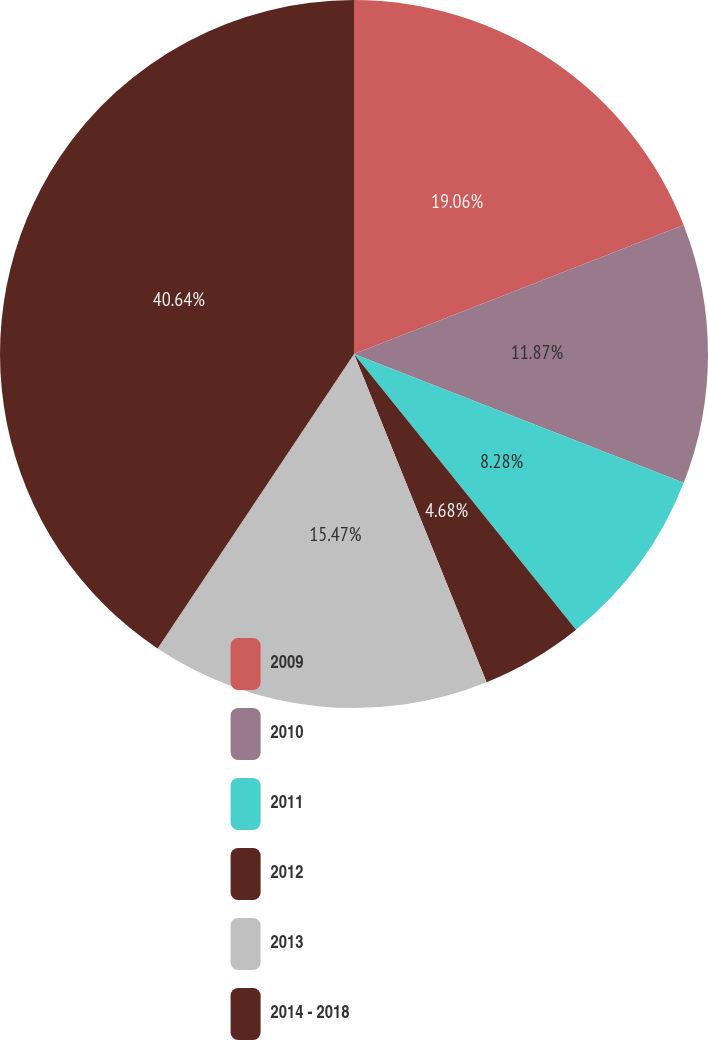<chart> <loc_0><loc_0><loc_500><loc_500><pie_chart><fcel>2009<fcel>2010<fcel>2011<fcel>2012<fcel>2013<fcel>2014 - 2018<nl><fcel>19.06%<fcel>11.87%<fcel>8.28%<fcel>4.68%<fcel>15.47%<fcel>40.64%<nl></chart> 